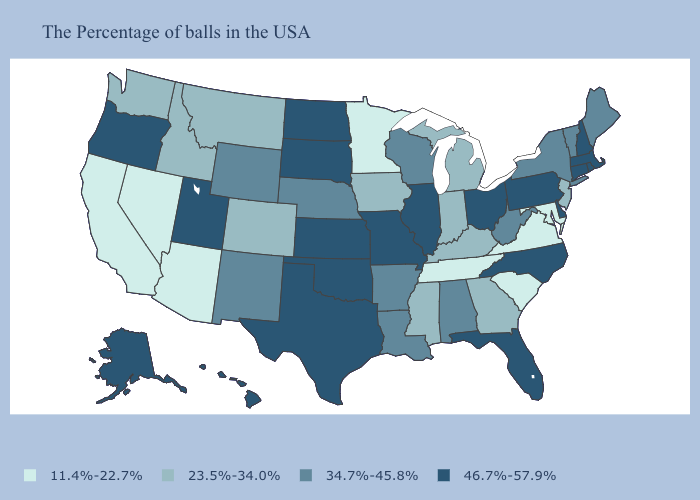Does Kentucky have a lower value than Mississippi?
Concise answer only. No. Among the states that border Iowa , which have the highest value?
Concise answer only. Illinois, Missouri, South Dakota. Name the states that have a value in the range 11.4%-22.7%?
Answer briefly. Maryland, Virginia, South Carolina, Tennessee, Minnesota, Arizona, Nevada, California. What is the value of Connecticut?
Be succinct. 46.7%-57.9%. What is the value of Mississippi?
Short answer required. 23.5%-34.0%. Is the legend a continuous bar?
Write a very short answer. No. Name the states that have a value in the range 34.7%-45.8%?
Concise answer only. Maine, Vermont, New York, West Virginia, Alabama, Wisconsin, Louisiana, Arkansas, Nebraska, Wyoming, New Mexico. What is the lowest value in the West?
Be succinct. 11.4%-22.7%. Name the states that have a value in the range 11.4%-22.7%?
Keep it brief. Maryland, Virginia, South Carolina, Tennessee, Minnesota, Arizona, Nevada, California. What is the value of Virginia?
Answer briefly. 11.4%-22.7%. Does Maryland have the highest value in the South?
Short answer required. No. How many symbols are there in the legend?
Keep it brief. 4. Name the states that have a value in the range 11.4%-22.7%?
Be succinct. Maryland, Virginia, South Carolina, Tennessee, Minnesota, Arizona, Nevada, California. Which states hav the highest value in the South?
Answer briefly. Delaware, North Carolina, Florida, Oklahoma, Texas. What is the value of Indiana?
Answer briefly. 23.5%-34.0%. 